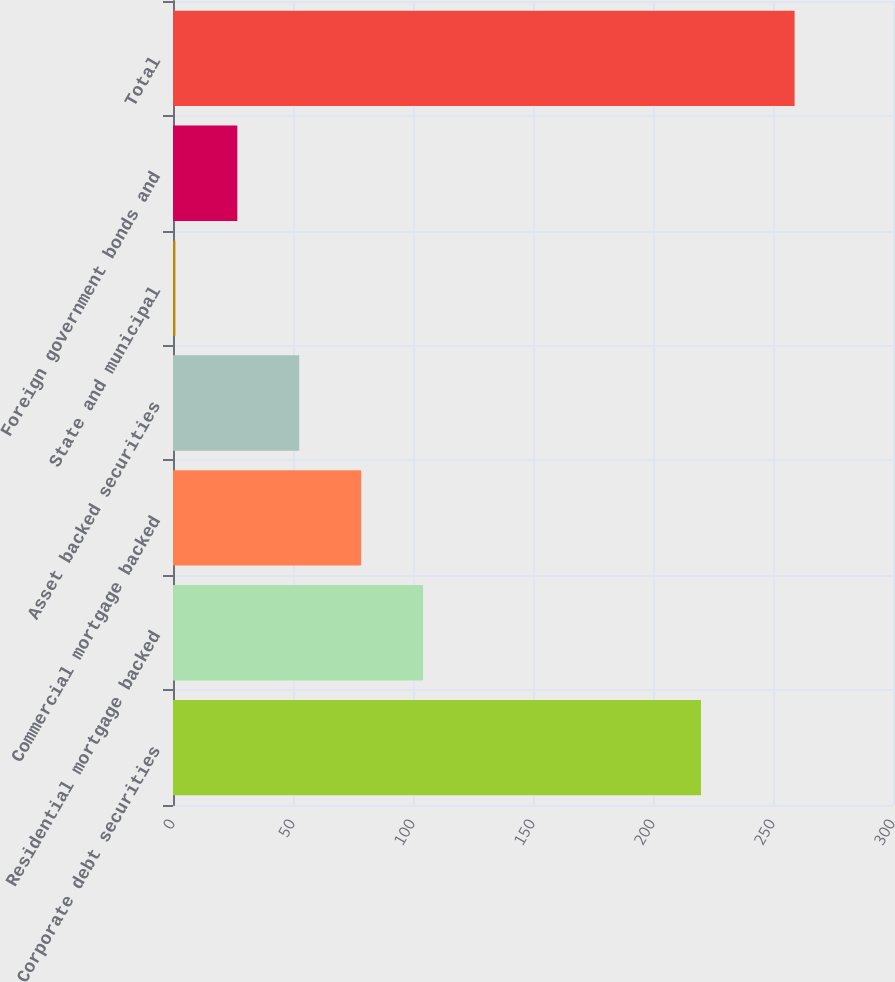Convert chart to OTSL. <chart><loc_0><loc_0><loc_500><loc_500><bar_chart><fcel>Corporate debt securities<fcel>Residential mortgage backed<fcel>Commercial mortgage backed<fcel>Asset backed securities<fcel>State and municipal<fcel>Foreign government bonds and<fcel>Total<nl><fcel>220<fcel>104.2<fcel>78.4<fcel>52.6<fcel>1<fcel>26.8<fcel>259<nl></chart> 